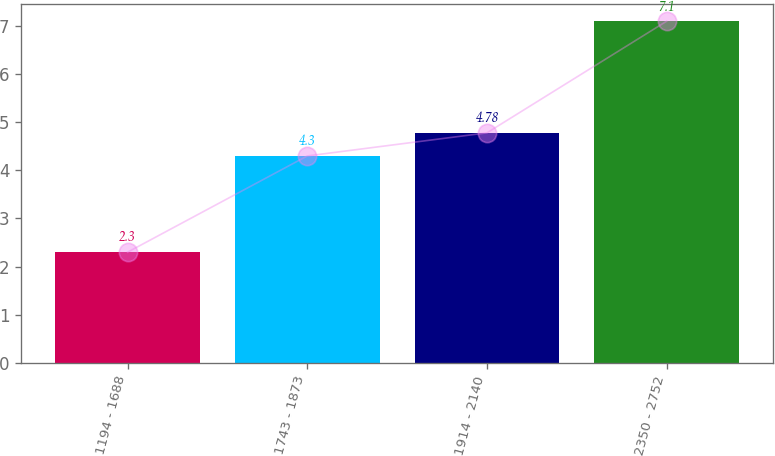<chart> <loc_0><loc_0><loc_500><loc_500><bar_chart><fcel>1194 - 1688<fcel>1743 - 1873<fcel>1914 - 2140<fcel>2350 - 2752<nl><fcel>2.3<fcel>4.3<fcel>4.78<fcel>7.1<nl></chart> 